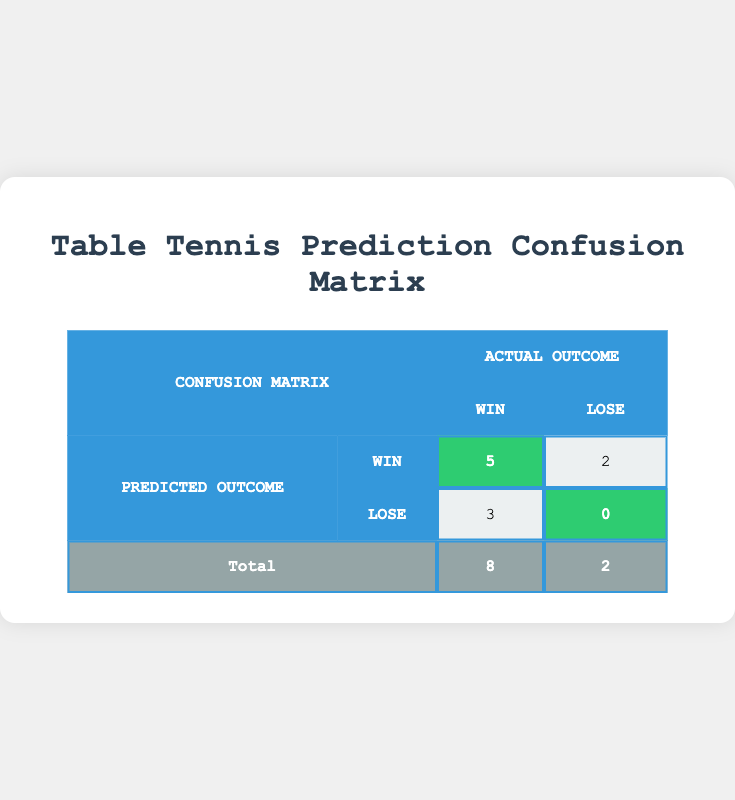What is the total number of matches predicted to be won? The total number of matches predicted to be won is calculated by summing the wins predicted correctly (5) and the wins predicted incorrectly (3). Thus, the total is 5 + 3 = 8.
Answer: 8 How many matches ended up with a loss predicted correctly? The table shows that there were a total of 2 matches where the winner was predicted correctly and these were both losses (0). Thus, the count is straightforward as found in the matrix.
Answer: 0 What percentage of matches were won correctly according to the predictions? To find this percentage, we take the number of correctly predicted wins (5) and divide it by the total number of matches (10), then multiply by 100. This results in (5/10) * 100 = 50%.
Answer: 50% Did any match show a predicted loss that resulted in a win? By examining the matrix, there are 3 matches where a loss was predicted, but all of them lost as well. Thus, there are no discrepancies where a predicted loss resulted in a win.
Answer: No In how many matches did actual winners win but were not predicted to win? We can see that 2 matches resulted in a win for the actual winners while they were not predicted as such. The table indicates that the actual winners were won by Dimitrij Ovtcharov and Liu Shiwen while their predictions indicated otherwise.
Answer: 2 What is the ratio of matches predicted to be wins to those predicted to be losses? To find the ratio, we observe that there were 5 predicted wins and 3 predicted losses, leading to the ratio of 5:3.
Answer: 5:3 How many matches had both predicted wins and actual wins? According to the confusion matrix, the matches with both predicted wins and actual wins are those which show up in the highlighted cells covered by the total wins predicted (5). Therefore, there are 5 matches.
Answer: 5 What is the total number of incorrect predictions made? To find the total incorrect predictions, we can add the predicted matches that lost (2) to those that were won by a player who was not predicted to win (3). Therefore, total incorrect predictions = 2 + 3 = 5.
Answer: 5 What is the total number of matches with correct winning predictions? The total number of matches with correct winning predictions is the count from the predicted wins row in the confusion matrix, which shows correctly predicted wins (5).
Answer: 5 